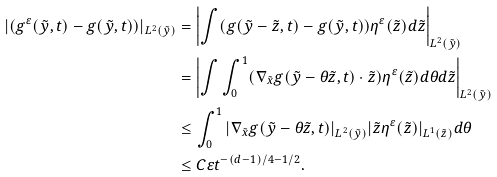Convert formula to latex. <formula><loc_0><loc_0><loc_500><loc_500>| ( g ^ { \varepsilon } ( \tilde { y } , t ) - g ( \tilde { y } , t ) ) | _ { L ^ { 2 } ( \tilde { y } ) } & = \left | \int ( g ( \tilde { y } - \tilde { z } , t ) - g ( \tilde { y } , t ) ) \eta ^ { \varepsilon } ( \tilde { z } ) d \tilde { z } \right | _ { L ^ { 2 } ( \tilde { y } ) } \\ & = \left | \int \int _ { 0 } ^ { 1 } ( \nabla _ { \tilde { x } } g ( \tilde { y } - \theta \tilde { z } , t ) \cdot \tilde { z } ) \eta ^ { \varepsilon } ( \tilde { z } ) d \theta d \tilde { z } \right | _ { L ^ { 2 } ( \tilde { y } ) } \\ & \leq \int _ { 0 } ^ { 1 } | \nabla _ { \tilde { x } } g ( \tilde { y } - \theta \tilde { z } , t ) | _ { L ^ { 2 } ( \tilde { y } ) } | \tilde { z } \eta ^ { \varepsilon } ( \tilde { z } ) | _ { L ^ { 1 } ( \tilde { z } ) } d \theta \\ & \leq C \varepsilon t ^ { - ( d - 1 ) / 4 - 1 / 2 } .</formula> 